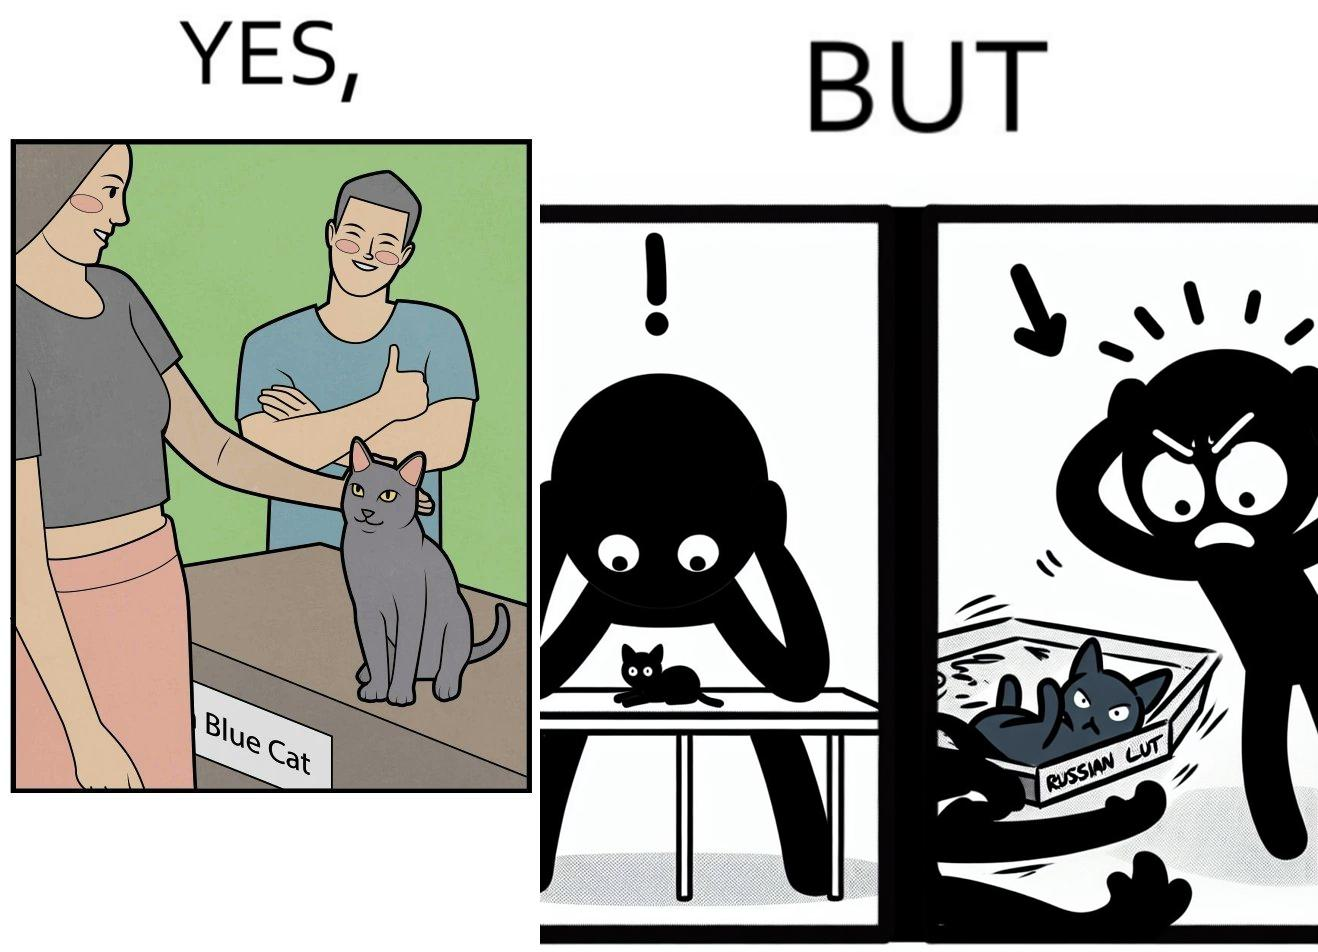What do you see in each half of this image? In the left part of the image: two happy people, where one of them is petting a cat sitting on a table, with a label "Blue Cat" written on the tabel. In the right part of the image: a worried person with hands on her head looking at a table with the label "Russian Blue Cat", while another angry person seems to be throwing away a cat. 